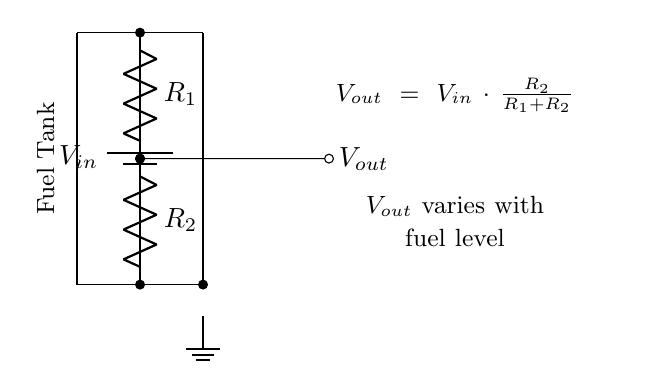What is the input voltage designation in this circuit? The input voltage is labeled as V_in in the circuit diagram, which indicates the source voltage applied across the voltage divider circuit.
Answer: V_in What are the resistor values labeled in the circuit? The resistors in the voltage divider are labeled R_1 and R_2, indicating the two resistive components used to divide the input voltage based on their resistance values.
Answer: R_1 and R_2 What is the output voltage expression shown in the circuit? The output voltage formula indicated in the diagram is V_out = V_in multiplied by R_2 over the sum of R_1 and R_2, which details how the output voltage is determined by the resistors and input voltage.
Answer: V_out = V_in * R_2 / (R_1 + R_2) How does the output voltage relate to fuel levels? According to the explanatory note in the circuit, V_out varies with the fuel level, meaning changes in fuel levels affect the resistance ratios and thus the output voltage of the divider.
Answer: V_out varies with fuel level What happens if R_1 has a very high resistance compared to R_2? If R_1 has a much higher resistance than R_2, then V_out would be significantly lower than V_in, as most of the voltage drops across R_1, leading to a decreased output voltage even with a constant input voltage.
Answer: V_out decreases What is the configuration type of this circuit? This is a voltage divider circuit, which uses two resistors in series to regulate and tap off a portion of the input voltage for monitoring and other applications.
Answer: Voltage divider 